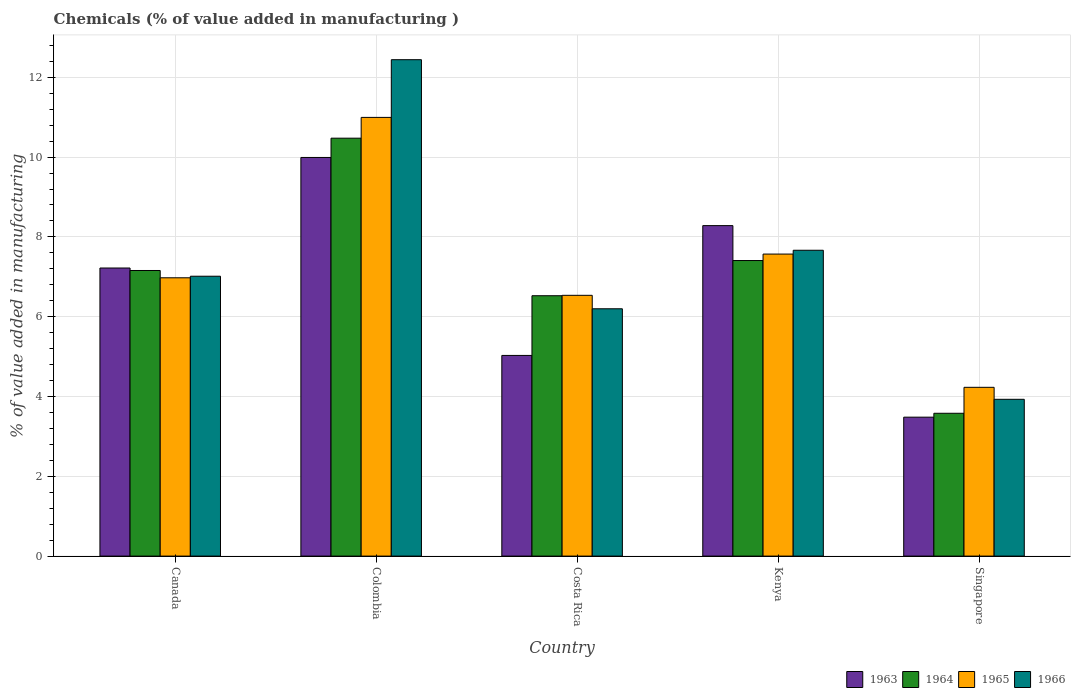How many different coloured bars are there?
Provide a succinct answer. 4. How many groups of bars are there?
Your answer should be very brief. 5. Are the number of bars per tick equal to the number of legend labels?
Provide a succinct answer. Yes. How many bars are there on the 3rd tick from the left?
Provide a succinct answer. 4. How many bars are there on the 2nd tick from the right?
Provide a succinct answer. 4. What is the label of the 5th group of bars from the left?
Ensure brevity in your answer.  Singapore. What is the value added in manufacturing chemicals in 1964 in Canada?
Provide a short and direct response. 7.16. Across all countries, what is the maximum value added in manufacturing chemicals in 1963?
Give a very brief answer. 9.99. Across all countries, what is the minimum value added in manufacturing chemicals in 1963?
Provide a short and direct response. 3.48. In which country was the value added in manufacturing chemicals in 1965 minimum?
Offer a very short reply. Singapore. What is the total value added in manufacturing chemicals in 1963 in the graph?
Your answer should be compact. 34.01. What is the difference between the value added in manufacturing chemicals in 1966 in Colombia and that in Kenya?
Ensure brevity in your answer.  4.78. What is the difference between the value added in manufacturing chemicals in 1964 in Canada and the value added in manufacturing chemicals in 1965 in Colombia?
Give a very brief answer. -3.84. What is the average value added in manufacturing chemicals in 1963 per country?
Offer a very short reply. 6.8. What is the difference between the value added in manufacturing chemicals of/in 1963 and value added in manufacturing chemicals of/in 1964 in Costa Rica?
Provide a short and direct response. -1.5. What is the ratio of the value added in manufacturing chemicals in 1963 in Canada to that in Kenya?
Give a very brief answer. 0.87. Is the difference between the value added in manufacturing chemicals in 1963 in Canada and Kenya greater than the difference between the value added in manufacturing chemicals in 1964 in Canada and Kenya?
Your answer should be very brief. No. What is the difference between the highest and the second highest value added in manufacturing chemicals in 1963?
Give a very brief answer. -1.71. What is the difference between the highest and the lowest value added in manufacturing chemicals in 1966?
Keep it short and to the point. 8.51. In how many countries, is the value added in manufacturing chemicals in 1963 greater than the average value added in manufacturing chemicals in 1963 taken over all countries?
Your answer should be very brief. 3. Is the sum of the value added in manufacturing chemicals in 1963 in Colombia and Singapore greater than the maximum value added in manufacturing chemicals in 1964 across all countries?
Ensure brevity in your answer.  Yes. What does the 4th bar from the left in Singapore represents?
Your answer should be compact. 1966. Are all the bars in the graph horizontal?
Your answer should be very brief. No. How many countries are there in the graph?
Offer a terse response. 5. Does the graph contain grids?
Your answer should be very brief. Yes. Where does the legend appear in the graph?
Your response must be concise. Bottom right. How are the legend labels stacked?
Offer a terse response. Horizontal. What is the title of the graph?
Your response must be concise. Chemicals (% of value added in manufacturing ). What is the label or title of the Y-axis?
Ensure brevity in your answer.  % of value added in manufacturing. What is the % of value added in manufacturing of 1963 in Canada?
Make the answer very short. 7.22. What is the % of value added in manufacturing of 1964 in Canada?
Ensure brevity in your answer.  7.16. What is the % of value added in manufacturing of 1965 in Canada?
Keep it short and to the point. 6.98. What is the % of value added in manufacturing of 1966 in Canada?
Your response must be concise. 7.01. What is the % of value added in manufacturing of 1963 in Colombia?
Provide a succinct answer. 9.99. What is the % of value added in manufacturing in 1964 in Colombia?
Offer a terse response. 10.47. What is the % of value added in manufacturing of 1965 in Colombia?
Offer a terse response. 10.99. What is the % of value added in manufacturing in 1966 in Colombia?
Provide a succinct answer. 12.44. What is the % of value added in manufacturing of 1963 in Costa Rica?
Give a very brief answer. 5.03. What is the % of value added in manufacturing of 1964 in Costa Rica?
Offer a terse response. 6.53. What is the % of value added in manufacturing of 1965 in Costa Rica?
Keep it short and to the point. 6.54. What is the % of value added in manufacturing in 1966 in Costa Rica?
Offer a very short reply. 6.2. What is the % of value added in manufacturing of 1963 in Kenya?
Offer a terse response. 8.28. What is the % of value added in manufacturing of 1964 in Kenya?
Provide a short and direct response. 7.41. What is the % of value added in manufacturing in 1965 in Kenya?
Your response must be concise. 7.57. What is the % of value added in manufacturing in 1966 in Kenya?
Ensure brevity in your answer.  7.67. What is the % of value added in manufacturing in 1963 in Singapore?
Provide a short and direct response. 3.48. What is the % of value added in manufacturing in 1964 in Singapore?
Your answer should be compact. 3.58. What is the % of value added in manufacturing in 1965 in Singapore?
Offer a terse response. 4.23. What is the % of value added in manufacturing in 1966 in Singapore?
Your response must be concise. 3.93. Across all countries, what is the maximum % of value added in manufacturing in 1963?
Your answer should be compact. 9.99. Across all countries, what is the maximum % of value added in manufacturing of 1964?
Make the answer very short. 10.47. Across all countries, what is the maximum % of value added in manufacturing of 1965?
Ensure brevity in your answer.  10.99. Across all countries, what is the maximum % of value added in manufacturing in 1966?
Provide a succinct answer. 12.44. Across all countries, what is the minimum % of value added in manufacturing in 1963?
Provide a succinct answer. 3.48. Across all countries, what is the minimum % of value added in manufacturing of 1964?
Keep it short and to the point. 3.58. Across all countries, what is the minimum % of value added in manufacturing of 1965?
Keep it short and to the point. 4.23. Across all countries, what is the minimum % of value added in manufacturing in 1966?
Make the answer very short. 3.93. What is the total % of value added in manufacturing in 1963 in the graph?
Provide a succinct answer. 34.01. What is the total % of value added in manufacturing of 1964 in the graph?
Make the answer very short. 35.15. What is the total % of value added in manufacturing in 1965 in the graph?
Your answer should be very brief. 36.31. What is the total % of value added in manufacturing of 1966 in the graph?
Provide a succinct answer. 37.25. What is the difference between the % of value added in manufacturing of 1963 in Canada and that in Colombia?
Provide a succinct answer. -2.77. What is the difference between the % of value added in manufacturing in 1964 in Canada and that in Colombia?
Make the answer very short. -3.32. What is the difference between the % of value added in manufacturing of 1965 in Canada and that in Colombia?
Give a very brief answer. -4.02. What is the difference between the % of value added in manufacturing in 1966 in Canada and that in Colombia?
Your answer should be compact. -5.43. What is the difference between the % of value added in manufacturing in 1963 in Canada and that in Costa Rica?
Make the answer very short. 2.19. What is the difference between the % of value added in manufacturing in 1964 in Canada and that in Costa Rica?
Your answer should be compact. 0.63. What is the difference between the % of value added in manufacturing in 1965 in Canada and that in Costa Rica?
Give a very brief answer. 0.44. What is the difference between the % of value added in manufacturing of 1966 in Canada and that in Costa Rica?
Ensure brevity in your answer.  0.82. What is the difference between the % of value added in manufacturing of 1963 in Canada and that in Kenya?
Offer a terse response. -1.06. What is the difference between the % of value added in manufacturing of 1964 in Canada and that in Kenya?
Make the answer very short. -0.25. What is the difference between the % of value added in manufacturing of 1965 in Canada and that in Kenya?
Keep it short and to the point. -0.59. What is the difference between the % of value added in manufacturing in 1966 in Canada and that in Kenya?
Your response must be concise. -0.65. What is the difference between the % of value added in manufacturing in 1963 in Canada and that in Singapore?
Your answer should be very brief. 3.74. What is the difference between the % of value added in manufacturing in 1964 in Canada and that in Singapore?
Keep it short and to the point. 3.58. What is the difference between the % of value added in manufacturing of 1965 in Canada and that in Singapore?
Offer a very short reply. 2.75. What is the difference between the % of value added in manufacturing of 1966 in Canada and that in Singapore?
Your answer should be very brief. 3.08. What is the difference between the % of value added in manufacturing in 1963 in Colombia and that in Costa Rica?
Offer a terse response. 4.96. What is the difference between the % of value added in manufacturing of 1964 in Colombia and that in Costa Rica?
Your response must be concise. 3.95. What is the difference between the % of value added in manufacturing in 1965 in Colombia and that in Costa Rica?
Ensure brevity in your answer.  4.46. What is the difference between the % of value added in manufacturing of 1966 in Colombia and that in Costa Rica?
Ensure brevity in your answer.  6.24. What is the difference between the % of value added in manufacturing in 1963 in Colombia and that in Kenya?
Keep it short and to the point. 1.71. What is the difference between the % of value added in manufacturing of 1964 in Colombia and that in Kenya?
Your answer should be very brief. 3.07. What is the difference between the % of value added in manufacturing of 1965 in Colombia and that in Kenya?
Provide a succinct answer. 3.43. What is the difference between the % of value added in manufacturing of 1966 in Colombia and that in Kenya?
Provide a succinct answer. 4.78. What is the difference between the % of value added in manufacturing of 1963 in Colombia and that in Singapore?
Offer a terse response. 6.51. What is the difference between the % of value added in manufacturing in 1964 in Colombia and that in Singapore?
Offer a very short reply. 6.89. What is the difference between the % of value added in manufacturing in 1965 in Colombia and that in Singapore?
Provide a short and direct response. 6.76. What is the difference between the % of value added in manufacturing in 1966 in Colombia and that in Singapore?
Keep it short and to the point. 8.51. What is the difference between the % of value added in manufacturing in 1963 in Costa Rica and that in Kenya?
Give a very brief answer. -3.25. What is the difference between the % of value added in manufacturing of 1964 in Costa Rica and that in Kenya?
Your answer should be very brief. -0.88. What is the difference between the % of value added in manufacturing of 1965 in Costa Rica and that in Kenya?
Provide a succinct answer. -1.03. What is the difference between the % of value added in manufacturing of 1966 in Costa Rica and that in Kenya?
Give a very brief answer. -1.47. What is the difference between the % of value added in manufacturing of 1963 in Costa Rica and that in Singapore?
Your response must be concise. 1.55. What is the difference between the % of value added in manufacturing in 1964 in Costa Rica and that in Singapore?
Provide a short and direct response. 2.95. What is the difference between the % of value added in manufacturing of 1965 in Costa Rica and that in Singapore?
Make the answer very short. 2.31. What is the difference between the % of value added in manufacturing in 1966 in Costa Rica and that in Singapore?
Your response must be concise. 2.27. What is the difference between the % of value added in manufacturing in 1963 in Kenya and that in Singapore?
Ensure brevity in your answer.  4.8. What is the difference between the % of value added in manufacturing of 1964 in Kenya and that in Singapore?
Ensure brevity in your answer.  3.83. What is the difference between the % of value added in manufacturing of 1965 in Kenya and that in Singapore?
Offer a terse response. 3.34. What is the difference between the % of value added in manufacturing in 1966 in Kenya and that in Singapore?
Make the answer very short. 3.74. What is the difference between the % of value added in manufacturing in 1963 in Canada and the % of value added in manufacturing in 1964 in Colombia?
Provide a succinct answer. -3.25. What is the difference between the % of value added in manufacturing in 1963 in Canada and the % of value added in manufacturing in 1965 in Colombia?
Make the answer very short. -3.77. What is the difference between the % of value added in manufacturing in 1963 in Canada and the % of value added in manufacturing in 1966 in Colombia?
Your answer should be very brief. -5.22. What is the difference between the % of value added in manufacturing in 1964 in Canada and the % of value added in manufacturing in 1965 in Colombia?
Offer a terse response. -3.84. What is the difference between the % of value added in manufacturing of 1964 in Canada and the % of value added in manufacturing of 1966 in Colombia?
Your answer should be very brief. -5.28. What is the difference between the % of value added in manufacturing of 1965 in Canada and the % of value added in manufacturing of 1966 in Colombia?
Your answer should be very brief. -5.47. What is the difference between the % of value added in manufacturing in 1963 in Canada and the % of value added in manufacturing in 1964 in Costa Rica?
Provide a succinct answer. 0.69. What is the difference between the % of value added in manufacturing of 1963 in Canada and the % of value added in manufacturing of 1965 in Costa Rica?
Your response must be concise. 0.68. What is the difference between the % of value added in manufacturing of 1963 in Canada and the % of value added in manufacturing of 1966 in Costa Rica?
Offer a terse response. 1.02. What is the difference between the % of value added in manufacturing in 1964 in Canada and the % of value added in manufacturing in 1965 in Costa Rica?
Provide a succinct answer. 0.62. What is the difference between the % of value added in manufacturing of 1964 in Canada and the % of value added in manufacturing of 1966 in Costa Rica?
Make the answer very short. 0.96. What is the difference between the % of value added in manufacturing of 1965 in Canada and the % of value added in manufacturing of 1966 in Costa Rica?
Provide a short and direct response. 0.78. What is the difference between the % of value added in manufacturing in 1963 in Canada and the % of value added in manufacturing in 1964 in Kenya?
Keep it short and to the point. -0.19. What is the difference between the % of value added in manufacturing of 1963 in Canada and the % of value added in manufacturing of 1965 in Kenya?
Provide a short and direct response. -0.35. What is the difference between the % of value added in manufacturing in 1963 in Canada and the % of value added in manufacturing in 1966 in Kenya?
Provide a short and direct response. -0.44. What is the difference between the % of value added in manufacturing in 1964 in Canada and the % of value added in manufacturing in 1965 in Kenya?
Provide a succinct answer. -0.41. What is the difference between the % of value added in manufacturing in 1964 in Canada and the % of value added in manufacturing in 1966 in Kenya?
Your response must be concise. -0.51. What is the difference between the % of value added in manufacturing of 1965 in Canada and the % of value added in manufacturing of 1966 in Kenya?
Your answer should be compact. -0.69. What is the difference between the % of value added in manufacturing in 1963 in Canada and the % of value added in manufacturing in 1964 in Singapore?
Keep it short and to the point. 3.64. What is the difference between the % of value added in manufacturing in 1963 in Canada and the % of value added in manufacturing in 1965 in Singapore?
Provide a succinct answer. 2.99. What is the difference between the % of value added in manufacturing in 1963 in Canada and the % of value added in manufacturing in 1966 in Singapore?
Ensure brevity in your answer.  3.29. What is the difference between the % of value added in manufacturing of 1964 in Canada and the % of value added in manufacturing of 1965 in Singapore?
Provide a succinct answer. 2.93. What is the difference between the % of value added in manufacturing of 1964 in Canada and the % of value added in manufacturing of 1966 in Singapore?
Your response must be concise. 3.23. What is the difference between the % of value added in manufacturing of 1965 in Canada and the % of value added in manufacturing of 1966 in Singapore?
Ensure brevity in your answer.  3.05. What is the difference between the % of value added in manufacturing in 1963 in Colombia and the % of value added in manufacturing in 1964 in Costa Rica?
Keep it short and to the point. 3.47. What is the difference between the % of value added in manufacturing in 1963 in Colombia and the % of value added in manufacturing in 1965 in Costa Rica?
Your answer should be very brief. 3.46. What is the difference between the % of value added in manufacturing of 1963 in Colombia and the % of value added in manufacturing of 1966 in Costa Rica?
Your answer should be compact. 3.79. What is the difference between the % of value added in manufacturing of 1964 in Colombia and the % of value added in manufacturing of 1965 in Costa Rica?
Provide a short and direct response. 3.94. What is the difference between the % of value added in manufacturing in 1964 in Colombia and the % of value added in manufacturing in 1966 in Costa Rica?
Give a very brief answer. 4.28. What is the difference between the % of value added in manufacturing of 1965 in Colombia and the % of value added in manufacturing of 1966 in Costa Rica?
Provide a short and direct response. 4.8. What is the difference between the % of value added in manufacturing of 1963 in Colombia and the % of value added in manufacturing of 1964 in Kenya?
Keep it short and to the point. 2.58. What is the difference between the % of value added in manufacturing in 1963 in Colombia and the % of value added in manufacturing in 1965 in Kenya?
Provide a succinct answer. 2.42. What is the difference between the % of value added in manufacturing in 1963 in Colombia and the % of value added in manufacturing in 1966 in Kenya?
Provide a succinct answer. 2.33. What is the difference between the % of value added in manufacturing in 1964 in Colombia and the % of value added in manufacturing in 1965 in Kenya?
Your response must be concise. 2.9. What is the difference between the % of value added in manufacturing of 1964 in Colombia and the % of value added in manufacturing of 1966 in Kenya?
Ensure brevity in your answer.  2.81. What is the difference between the % of value added in manufacturing in 1965 in Colombia and the % of value added in manufacturing in 1966 in Kenya?
Keep it short and to the point. 3.33. What is the difference between the % of value added in manufacturing of 1963 in Colombia and the % of value added in manufacturing of 1964 in Singapore?
Give a very brief answer. 6.41. What is the difference between the % of value added in manufacturing in 1963 in Colombia and the % of value added in manufacturing in 1965 in Singapore?
Give a very brief answer. 5.76. What is the difference between the % of value added in manufacturing in 1963 in Colombia and the % of value added in manufacturing in 1966 in Singapore?
Your answer should be very brief. 6.06. What is the difference between the % of value added in manufacturing of 1964 in Colombia and the % of value added in manufacturing of 1965 in Singapore?
Make the answer very short. 6.24. What is the difference between the % of value added in manufacturing in 1964 in Colombia and the % of value added in manufacturing in 1966 in Singapore?
Your answer should be compact. 6.54. What is the difference between the % of value added in manufacturing of 1965 in Colombia and the % of value added in manufacturing of 1966 in Singapore?
Ensure brevity in your answer.  7.07. What is the difference between the % of value added in manufacturing of 1963 in Costa Rica and the % of value added in manufacturing of 1964 in Kenya?
Make the answer very short. -2.38. What is the difference between the % of value added in manufacturing of 1963 in Costa Rica and the % of value added in manufacturing of 1965 in Kenya?
Your response must be concise. -2.54. What is the difference between the % of value added in manufacturing in 1963 in Costa Rica and the % of value added in manufacturing in 1966 in Kenya?
Give a very brief answer. -2.64. What is the difference between the % of value added in manufacturing of 1964 in Costa Rica and the % of value added in manufacturing of 1965 in Kenya?
Make the answer very short. -1.04. What is the difference between the % of value added in manufacturing of 1964 in Costa Rica and the % of value added in manufacturing of 1966 in Kenya?
Provide a succinct answer. -1.14. What is the difference between the % of value added in manufacturing in 1965 in Costa Rica and the % of value added in manufacturing in 1966 in Kenya?
Give a very brief answer. -1.13. What is the difference between the % of value added in manufacturing in 1963 in Costa Rica and the % of value added in manufacturing in 1964 in Singapore?
Make the answer very short. 1.45. What is the difference between the % of value added in manufacturing of 1963 in Costa Rica and the % of value added in manufacturing of 1965 in Singapore?
Offer a terse response. 0.8. What is the difference between the % of value added in manufacturing of 1963 in Costa Rica and the % of value added in manufacturing of 1966 in Singapore?
Your answer should be compact. 1.1. What is the difference between the % of value added in manufacturing in 1964 in Costa Rica and the % of value added in manufacturing in 1965 in Singapore?
Make the answer very short. 2.3. What is the difference between the % of value added in manufacturing in 1964 in Costa Rica and the % of value added in manufacturing in 1966 in Singapore?
Give a very brief answer. 2.6. What is the difference between the % of value added in manufacturing in 1965 in Costa Rica and the % of value added in manufacturing in 1966 in Singapore?
Make the answer very short. 2.61. What is the difference between the % of value added in manufacturing of 1963 in Kenya and the % of value added in manufacturing of 1964 in Singapore?
Keep it short and to the point. 4.7. What is the difference between the % of value added in manufacturing in 1963 in Kenya and the % of value added in manufacturing in 1965 in Singapore?
Your answer should be very brief. 4.05. What is the difference between the % of value added in manufacturing in 1963 in Kenya and the % of value added in manufacturing in 1966 in Singapore?
Provide a succinct answer. 4.35. What is the difference between the % of value added in manufacturing in 1964 in Kenya and the % of value added in manufacturing in 1965 in Singapore?
Provide a short and direct response. 3.18. What is the difference between the % of value added in manufacturing in 1964 in Kenya and the % of value added in manufacturing in 1966 in Singapore?
Provide a short and direct response. 3.48. What is the difference between the % of value added in manufacturing in 1965 in Kenya and the % of value added in manufacturing in 1966 in Singapore?
Provide a succinct answer. 3.64. What is the average % of value added in manufacturing of 1963 per country?
Make the answer very short. 6.8. What is the average % of value added in manufacturing in 1964 per country?
Give a very brief answer. 7.03. What is the average % of value added in manufacturing of 1965 per country?
Keep it short and to the point. 7.26. What is the average % of value added in manufacturing in 1966 per country?
Your answer should be very brief. 7.45. What is the difference between the % of value added in manufacturing in 1963 and % of value added in manufacturing in 1964 in Canada?
Your response must be concise. 0.06. What is the difference between the % of value added in manufacturing in 1963 and % of value added in manufacturing in 1965 in Canada?
Your response must be concise. 0.25. What is the difference between the % of value added in manufacturing in 1963 and % of value added in manufacturing in 1966 in Canada?
Make the answer very short. 0.21. What is the difference between the % of value added in manufacturing in 1964 and % of value added in manufacturing in 1965 in Canada?
Your answer should be compact. 0.18. What is the difference between the % of value added in manufacturing of 1964 and % of value added in manufacturing of 1966 in Canada?
Your answer should be compact. 0.14. What is the difference between the % of value added in manufacturing in 1965 and % of value added in manufacturing in 1966 in Canada?
Make the answer very short. -0.04. What is the difference between the % of value added in manufacturing of 1963 and % of value added in manufacturing of 1964 in Colombia?
Give a very brief answer. -0.48. What is the difference between the % of value added in manufacturing of 1963 and % of value added in manufacturing of 1965 in Colombia?
Your response must be concise. -1. What is the difference between the % of value added in manufacturing of 1963 and % of value added in manufacturing of 1966 in Colombia?
Provide a succinct answer. -2.45. What is the difference between the % of value added in manufacturing in 1964 and % of value added in manufacturing in 1965 in Colombia?
Your answer should be compact. -0.52. What is the difference between the % of value added in manufacturing of 1964 and % of value added in manufacturing of 1966 in Colombia?
Give a very brief answer. -1.97. What is the difference between the % of value added in manufacturing of 1965 and % of value added in manufacturing of 1966 in Colombia?
Your answer should be compact. -1.45. What is the difference between the % of value added in manufacturing of 1963 and % of value added in manufacturing of 1964 in Costa Rica?
Keep it short and to the point. -1.5. What is the difference between the % of value added in manufacturing of 1963 and % of value added in manufacturing of 1965 in Costa Rica?
Your answer should be compact. -1.51. What is the difference between the % of value added in manufacturing in 1963 and % of value added in manufacturing in 1966 in Costa Rica?
Provide a succinct answer. -1.17. What is the difference between the % of value added in manufacturing of 1964 and % of value added in manufacturing of 1965 in Costa Rica?
Your answer should be very brief. -0.01. What is the difference between the % of value added in manufacturing in 1964 and % of value added in manufacturing in 1966 in Costa Rica?
Provide a succinct answer. 0.33. What is the difference between the % of value added in manufacturing in 1965 and % of value added in manufacturing in 1966 in Costa Rica?
Provide a succinct answer. 0.34. What is the difference between the % of value added in manufacturing in 1963 and % of value added in manufacturing in 1964 in Kenya?
Provide a succinct answer. 0.87. What is the difference between the % of value added in manufacturing in 1963 and % of value added in manufacturing in 1965 in Kenya?
Your answer should be very brief. 0.71. What is the difference between the % of value added in manufacturing in 1963 and % of value added in manufacturing in 1966 in Kenya?
Make the answer very short. 0.62. What is the difference between the % of value added in manufacturing in 1964 and % of value added in manufacturing in 1965 in Kenya?
Your response must be concise. -0.16. What is the difference between the % of value added in manufacturing of 1964 and % of value added in manufacturing of 1966 in Kenya?
Offer a very short reply. -0.26. What is the difference between the % of value added in manufacturing of 1965 and % of value added in manufacturing of 1966 in Kenya?
Give a very brief answer. -0.1. What is the difference between the % of value added in manufacturing in 1963 and % of value added in manufacturing in 1964 in Singapore?
Keep it short and to the point. -0.1. What is the difference between the % of value added in manufacturing of 1963 and % of value added in manufacturing of 1965 in Singapore?
Provide a succinct answer. -0.75. What is the difference between the % of value added in manufacturing of 1963 and % of value added in manufacturing of 1966 in Singapore?
Provide a short and direct response. -0.45. What is the difference between the % of value added in manufacturing of 1964 and % of value added in manufacturing of 1965 in Singapore?
Your answer should be very brief. -0.65. What is the difference between the % of value added in manufacturing of 1964 and % of value added in manufacturing of 1966 in Singapore?
Your response must be concise. -0.35. What is the difference between the % of value added in manufacturing of 1965 and % of value added in manufacturing of 1966 in Singapore?
Give a very brief answer. 0.3. What is the ratio of the % of value added in manufacturing in 1963 in Canada to that in Colombia?
Offer a very short reply. 0.72. What is the ratio of the % of value added in manufacturing of 1964 in Canada to that in Colombia?
Offer a terse response. 0.68. What is the ratio of the % of value added in manufacturing in 1965 in Canada to that in Colombia?
Your answer should be very brief. 0.63. What is the ratio of the % of value added in manufacturing of 1966 in Canada to that in Colombia?
Provide a succinct answer. 0.56. What is the ratio of the % of value added in manufacturing in 1963 in Canada to that in Costa Rica?
Your answer should be compact. 1.44. What is the ratio of the % of value added in manufacturing in 1964 in Canada to that in Costa Rica?
Provide a succinct answer. 1.1. What is the ratio of the % of value added in manufacturing of 1965 in Canada to that in Costa Rica?
Your answer should be compact. 1.07. What is the ratio of the % of value added in manufacturing in 1966 in Canada to that in Costa Rica?
Provide a short and direct response. 1.13. What is the ratio of the % of value added in manufacturing of 1963 in Canada to that in Kenya?
Provide a short and direct response. 0.87. What is the ratio of the % of value added in manufacturing of 1964 in Canada to that in Kenya?
Give a very brief answer. 0.97. What is the ratio of the % of value added in manufacturing of 1965 in Canada to that in Kenya?
Offer a terse response. 0.92. What is the ratio of the % of value added in manufacturing in 1966 in Canada to that in Kenya?
Provide a succinct answer. 0.92. What is the ratio of the % of value added in manufacturing in 1963 in Canada to that in Singapore?
Keep it short and to the point. 2.07. What is the ratio of the % of value added in manufacturing of 1964 in Canada to that in Singapore?
Provide a succinct answer. 2. What is the ratio of the % of value added in manufacturing of 1965 in Canada to that in Singapore?
Make the answer very short. 1.65. What is the ratio of the % of value added in manufacturing in 1966 in Canada to that in Singapore?
Give a very brief answer. 1.78. What is the ratio of the % of value added in manufacturing in 1963 in Colombia to that in Costa Rica?
Give a very brief answer. 1.99. What is the ratio of the % of value added in manufacturing in 1964 in Colombia to that in Costa Rica?
Keep it short and to the point. 1.61. What is the ratio of the % of value added in manufacturing in 1965 in Colombia to that in Costa Rica?
Give a very brief answer. 1.68. What is the ratio of the % of value added in manufacturing of 1966 in Colombia to that in Costa Rica?
Ensure brevity in your answer.  2.01. What is the ratio of the % of value added in manufacturing in 1963 in Colombia to that in Kenya?
Provide a succinct answer. 1.21. What is the ratio of the % of value added in manufacturing of 1964 in Colombia to that in Kenya?
Make the answer very short. 1.41. What is the ratio of the % of value added in manufacturing of 1965 in Colombia to that in Kenya?
Provide a short and direct response. 1.45. What is the ratio of the % of value added in manufacturing in 1966 in Colombia to that in Kenya?
Offer a terse response. 1.62. What is the ratio of the % of value added in manufacturing in 1963 in Colombia to that in Singapore?
Your answer should be very brief. 2.87. What is the ratio of the % of value added in manufacturing of 1964 in Colombia to that in Singapore?
Offer a terse response. 2.93. What is the ratio of the % of value added in manufacturing of 1965 in Colombia to that in Singapore?
Provide a succinct answer. 2.6. What is the ratio of the % of value added in manufacturing in 1966 in Colombia to that in Singapore?
Offer a terse response. 3.17. What is the ratio of the % of value added in manufacturing in 1963 in Costa Rica to that in Kenya?
Give a very brief answer. 0.61. What is the ratio of the % of value added in manufacturing of 1964 in Costa Rica to that in Kenya?
Ensure brevity in your answer.  0.88. What is the ratio of the % of value added in manufacturing in 1965 in Costa Rica to that in Kenya?
Offer a terse response. 0.86. What is the ratio of the % of value added in manufacturing of 1966 in Costa Rica to that in Kenya?
Offer a very short reply. 0.81. What is the ratio of the % of value added in manufacturing of 1963 in Costa Rica to that in Singapore?
Offer a terse response. 1.44. What is the ratio of the % of value added in manufacturing of 1964 in Costa Rica to that in Singapore?
Offer a very short reply. 1.82. What is the ratio of the % of value added in manufacturing in 1965 in Costa Rica to that in Singapore?
Offer a very short reply. 1.55. What is the ratio of the % of value added in manufacturing of 1966 in Costa Rica to that in Singapore?
Offer a very short reply. 1.58. What is the ratio of the % of value added in manufacturing in 1963 in Kenya to that in Singapore?
Keep it short and to the point. 2.38. What is the ratio of the % of value added in manufacturing of 1964 in Kenya to that in Singapore?
Your response must be concise. 2.07. What is the ratio of the % of value added in manufacturing of 1965 in Kenya to that in Singapore?
Provide a short and direct response. 1.79. What is the ratio of the % of value added in manufacturing of 1966 in Kenya to that in Singapore?
Your response must be concise. 1.95. What is the difference between the highest and the second highest % of value added in manufacturing of 1963?
Provide a succinct answer. 1.71. What is the difference between the highest and the second highest % of value added in manufacturing of 1964?
Give a very brief answer. 3.07. What is the difference between the highest and the second highest % of value added in manufacturing in 1965?
Keep it short and to the point. 3.43. What is the difference between the highest and the second highest % of value added in manufacturing of 1966?
Keep it short and to the point. 4.78. What is the difference between the highest and the lowest % of value added in manufacturing of 1963?
Offer a very short reply. 6.51. What is the difference between the highest and the lowest % of value added in manufacturing of 1964?
Ensure brevity in your answer.  6.89. What is the difference between the highest and the lowest % of value added in manufacturing in 1965?
Provide a succinct answer. 6.76. What is the difference between the highest and the lowest % of value added in manufacturing in 1966?
Make the answer very short. 8.51. 